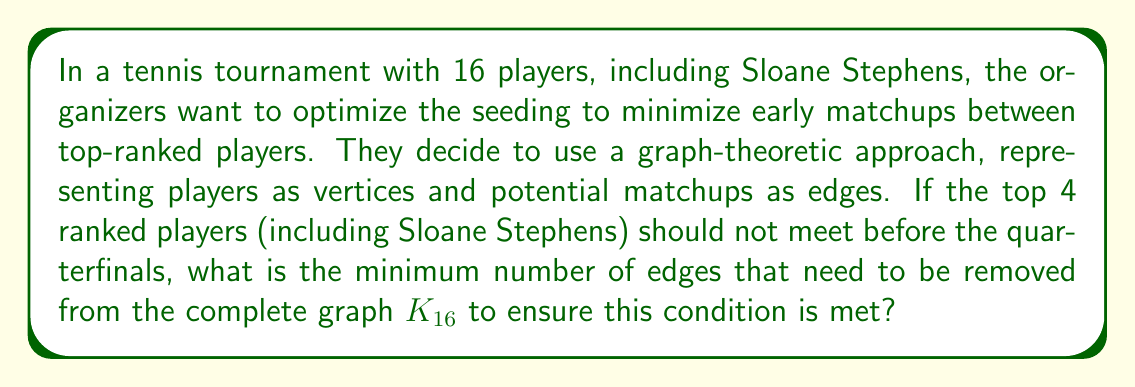Provide a solution to this math problem. Let's approach this step-by-step:

1) In a 16-player tournament, there are 4 rounds: Round of 16, Quarterfinals, Semifinals, and Finals.

2) We want the top 4 players (including Sloane Stephens) to not meet before the quarterfinals. This means they should be in different quarters of the draw.

3) In graph theory terms, we start with a complete graph $K_{16}$ where every player could potentially play every other player.

4) To ensure the top 4 players don't meet before the quarterfinals, we need to remove the edges between them in the first two rounds.

5) In the complete graph $K_{16}$, the number of edges between any 4 vertices is:

   $$\binom{4}{2} = \frac{4!}{2!(4-2)!} = 6$$

6) These 6 edges represent the potential matchups between the top 4 players in the first two rounds, which we need to remove.

7) Therefore, the minimum number of edges that need to be removed is 6.

This graph-theoretic approach ensures that Sloane Stephens and the other top 3 players will be placed in different quarters of the draw, optimizing the tournament structure.
Answer: 6 edges 